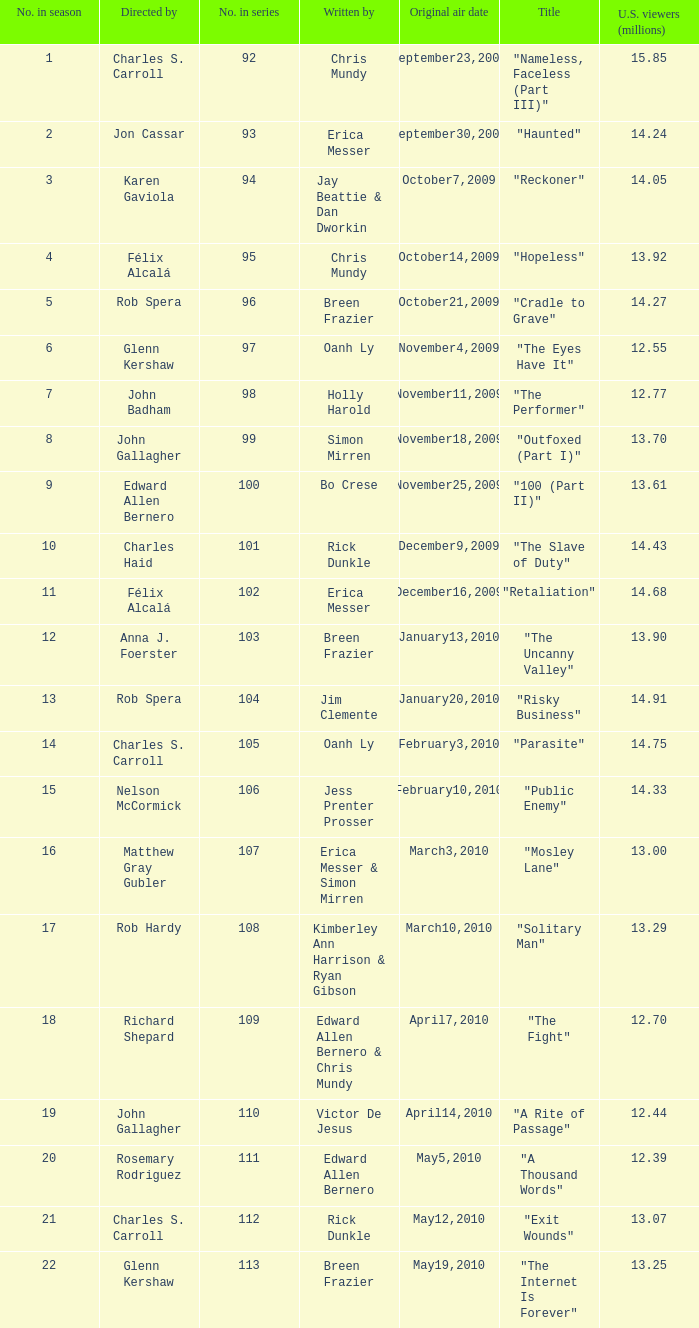Who wrote episode number 109 in the series? Edward Allen Bernero & Chris Mundy. 